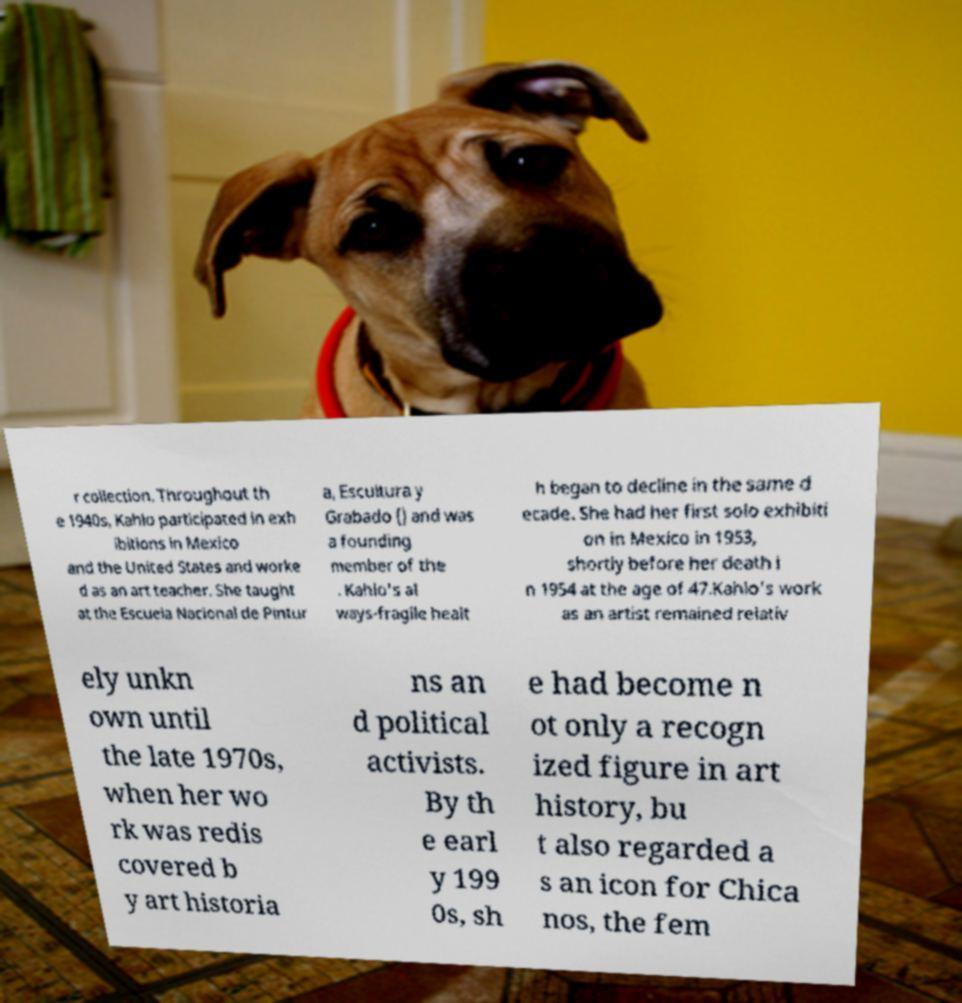I need the written content from this picture converted into text. Can you do that? r collection. Throughout th e 1940s, Kahlo participated in exh ibitions in Mexico and the United States and worke d as an art teacher. She taught at the Escuela Nacional de Pintur a, Escultura y Grabado () and was a founding member of the . Kahlo's al ways-fragile healt h began to decline in the same d ecade. She had her first solo exhibiti on in Mexico in 1953, shortly before her death i n 1954 at the age of 47.Kahlo's work as an artist remained relativ ely unkn own until the late 1970s, when her wo rk was redis covered b y art historia ns an d political activists. By th e earl y 199 0s, sh e had become n ot only a recogn ized figure in art history, bu t also regarded a s an icon for Chica nos, the fem 